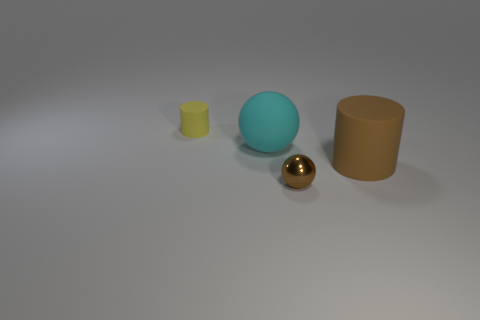Could you describe the lighting and shadows in the scene? The image has soft, diffused lighting, which might suggest an overcast sky or a studio setting with a softbox. Shadows are present but not very harsh, indicating the light source is not extremely bright or direct. The shadow direction suggests a single light source to the upper right of the objects. 